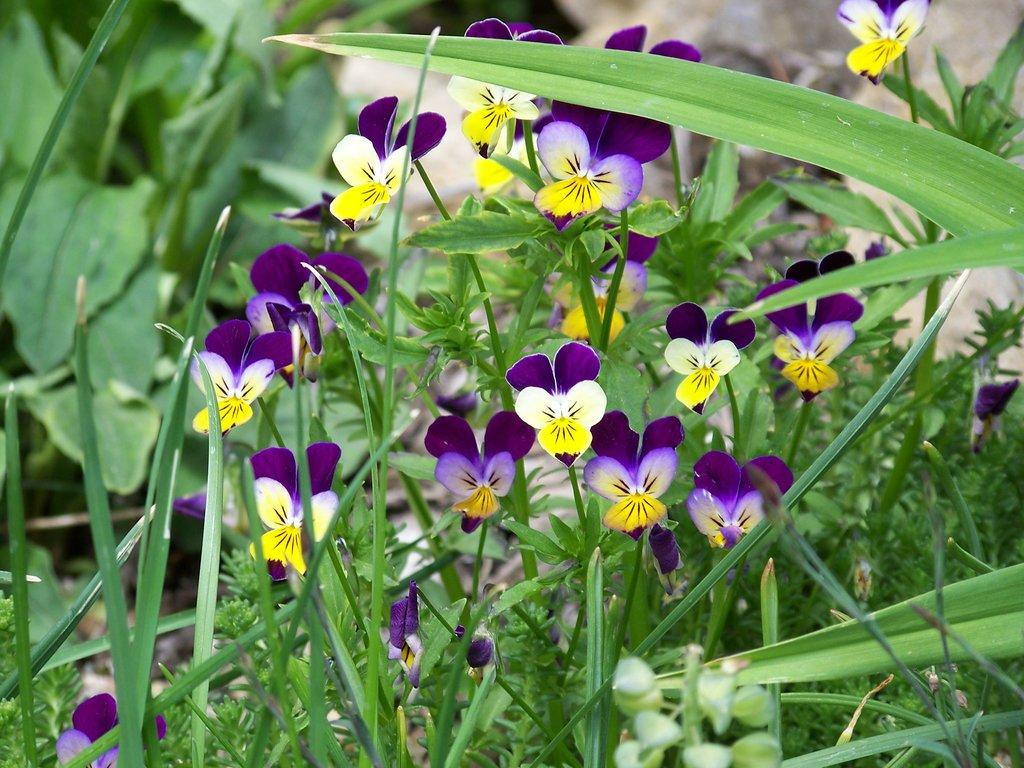What type of living organisms can be seen in the image? Plants can be seen in the image. Do the plants in the image have any specific features? Yes, the plants have flowers. Can you see the cap of the plant in the image? There is no cap present on the plants in the image. Is there any indication of a battle taking place among the plants in the image? There is no battle or any sign of conflict among the plants in the image. 